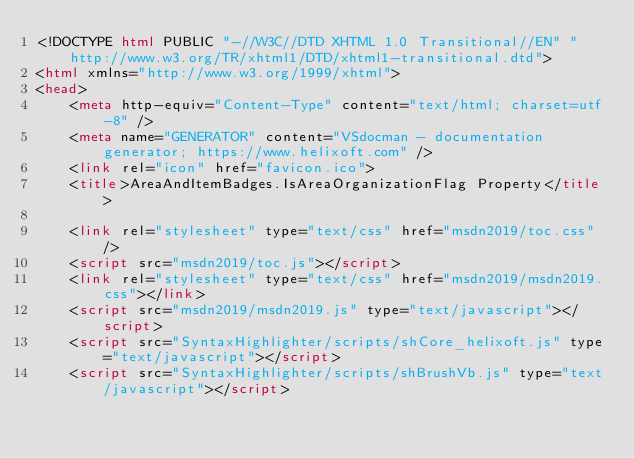<code> <loc_0><loc_0><loc_500><loc_500><_HTML_><!DOCTYPE html PUBLIC "-//W3C//DTD XHTML 1.0 Transitional//EN" "http://www.w3.org/TR/xhtml1/DTD/xhtml1-transitional.dtd">
<html xmlns="http://www.w3.org/1999/xhtml">
<head>
	<meta http-equiv="Content-Type" content="text/html; charset=utf-8" />
	<meta name="GENERATOR" content="VSdocman - documentation generator; https://www.helixoft.com" />
	<link rel="icon" href="favicon.ico">
	<title>AreaAndItemBadges.IsAreaOrganizationFlag Property</title>

	<link rel="stylesheet" type="text/css" href="msdn2019/toc.css" />
	<script src="msdn2019/toc.js"></script>
	<link rel="stylesheet" type="text/css" href="msdn2019/msdn2019.css"></link>
	<script src="msdn2019/msdn2019.js" type="text/javascript"></script>
	<script src="SyntaxHighlighter/scripts/shCore_helixoft.js" type="text/javascript"></script>
	<script src="SyntaxHighlighter/scripts/shBrushVb.js" type="text/javascript"></script></code> 